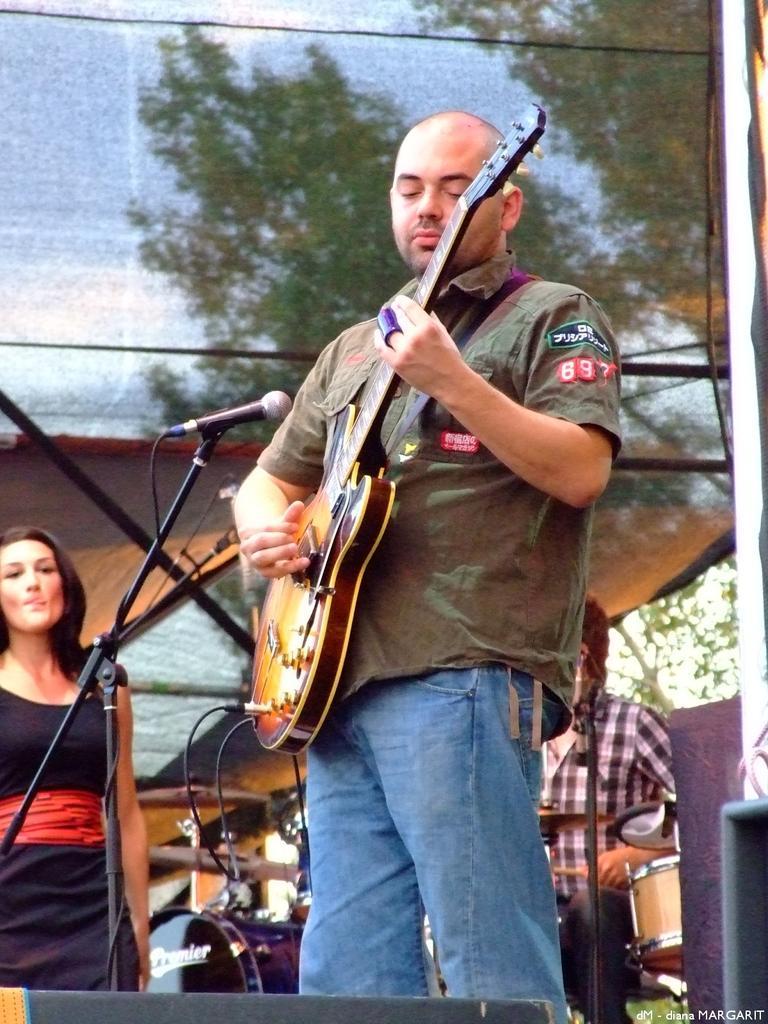Can you describe this image briefly? This man is standing and playing a guitar in-front of mic. On banner there are trees. For this woman in black dress is stunning. These are musical instruments. This man is playing this musical instruments. 